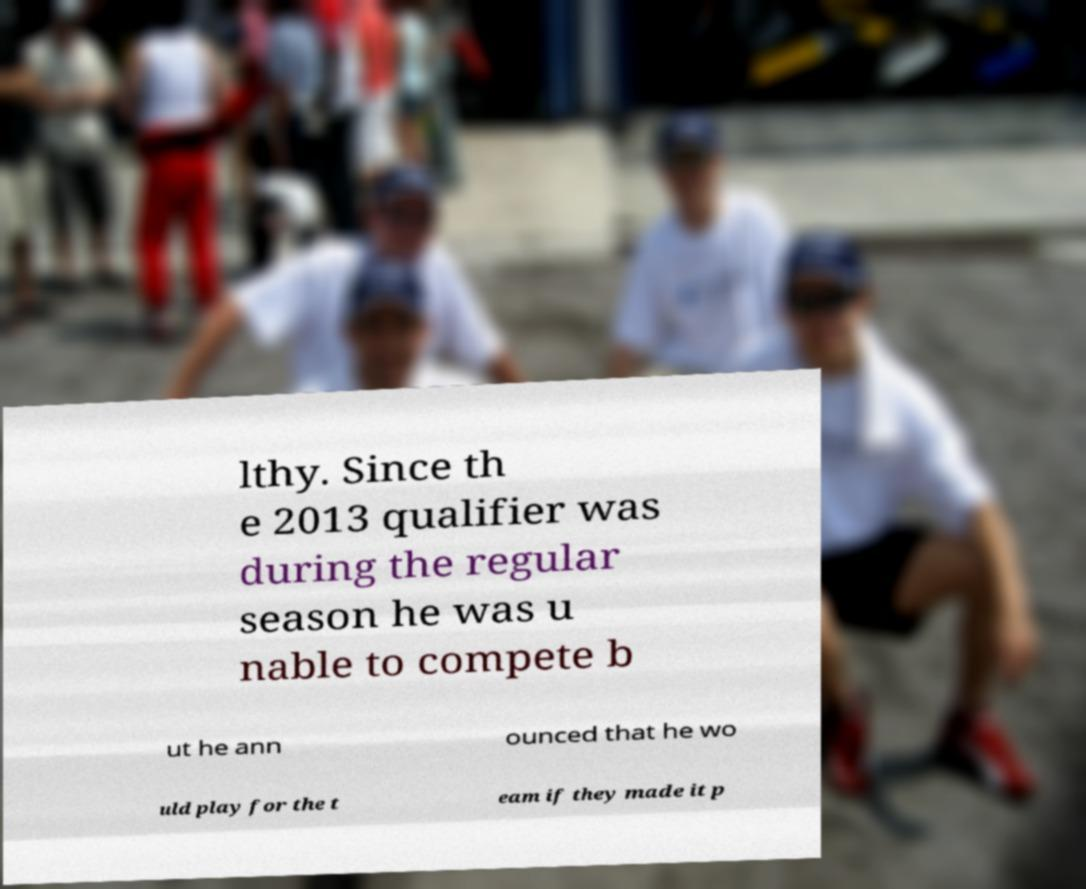Could you extract and type out the text from this image? lthy. Since th e 2013 qualifier was during the regular season he was u nable to compete b ut he ann ounced that he wo uld play for the t eam if they made it p 